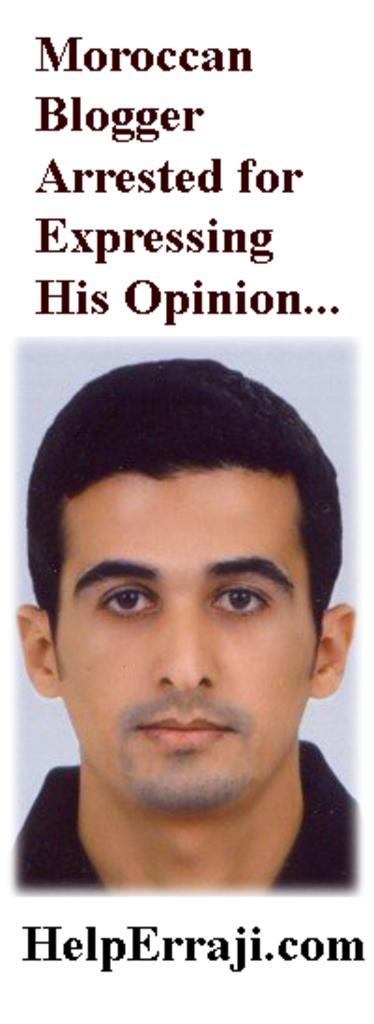What is the main subject of the image? There is a picture of a man in the image. What can be seen above the picture of the man? There is text on the top of the image. What can be seen below the picture of the man? There is text on the bottom of the image. Can you tell me how many times the man in the image has been burned? There is no information about the man being burned in the image, so it cannot be determined from the image. 